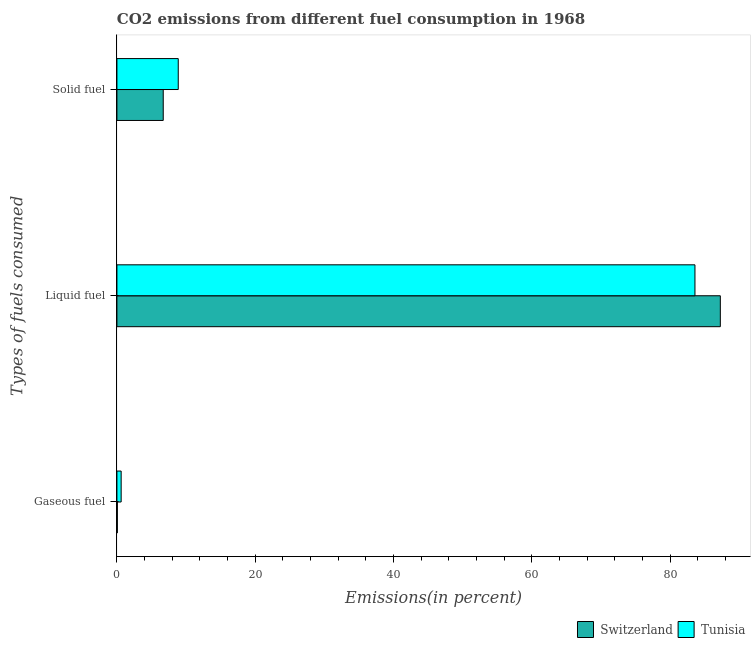How many groups of bars are there?
Your answer should be compact. 3. Are the number of bars per tick equal to the number of legend labels?
Make the answer very short. Yes. How many bars are there on the 2nd tick from the top?
Your answer should be compact. 2. How many bars are there on the 2nd tick from the bottom?
Give a very brief answer. 2. What is the label of the 3rd group of bars from the top?
Offer a very short reply. Gaseous fuel. What is the percentage of liquid fuel emission in Switzerland?
Give a very brief answer. 87.26. Across all countries, what is the maximum percentage of gaseous fuel emission?
Offer a very short reply. 0.61. Across all countries, what is the minimum percentage of liquid fuel emission?
Your answer should be very brief. 83.59. In which country was the percentage of solid fuel emission maximum?
Your answer should be compact. Tunisia. In which country was the percentage of liquid fuel emission minimum?
Your answer should be very brief. Tunisia. What is the total percentage of liquid fuel emission in the graph?
Your answer should be compact. 170.85. What is the difference between the percentage of liquid fuel emission in Tunisia and that in Switzerland?
Your answer should be very brief. -3.67. What is the difference between the percentage of liquid fuel emission in Tunisia and the percentage of gaseous fuel emission in Switzerland?
Give a very brief answer. 83.53. What is the average percentage of solid fuel emission per country?
Your answer should be very brief. 7.78. What is the difference between the percentage of liquid fuel emission and percentage of solid fuel emission in Switzerland?
Offer a terse response. 80.56. What is the ratio of the percentage of solid fuel emission in Switzerland to that in Tunisia?
Give a very brief answer. 0.76. Is the percentage of liquid fuel emission in Switzerland less than that in Tunisia?
Offer a terse response. No. What is the difference between the highest and the second highest percentage of gaseous fuel emission?
Offer a very short reply. 0.55. What is the difference between the highest and the lowest percentage of gaseous fuel emission?
Give a very brief answer. 0.55. What does the 2nd bar from the top in Liquid fuel represents?
Keep it short and to the point. Switzerland. What does the 1st bar from the bottom in Solid fuel represents?
Provide a succinct answer. Switzerland. How many bars are there?
Give a very brief answer. 6. Are all the bars in the graph horizontal?
Your answer should be very brief. Yes. Are the values on the major ticks of X-axis written in scientific E-notation?
Offer a terse response. No. Does the graph contain any zero values?
Ensure brevity in your answer.  No. Where does the legend appear in the graph?
Give a very brief answer. Bottom right. How are the legend labels stacked?
Your response must be concise. Horizontal. What is the title of the graph?
Your answer should be very brief. CO2 emissions from different fuel consumption in 1968. Does "Turkey" appear as one of the legend labels in the graph?
Provide a succinct answer. No. What is the label or title of the X-axis?
Keep it short and to the point. Emissions(in percent). What is the label or title of the Y-axis?
Offer a terse response. Types of fuels consumed. What is the Emissions(in percent) of Switzerland in Gaseous fuel?
Offer a very short reply. 0.06. What is the Emissions(in percent) in Tunisia in Gaseous fuel?
Give a very brief answer. 0.61. What is the Emissions(in percent) of Switzerland in Liquid fuel?
Your answer should be very brief. 87.26. What is the Emissions(in percent) of Tunisia in Liquid fuel?
Your answer should be very brief. 83.59. What is the Emissions(in percent) in Switzerland in Solid fuel?
Offer a terse response. 6.7. What is the Emissions(in percent) of Tunisia in Solid fuel?
Your answer should be compact. 8.87. Across all Types of fuels consumed, what is the maximum Emissions(in percent) in Switzerland?
Your answer should be compact. 87.26. Across all Types of fuels consumed, what is the maximum Emissions(in percent) of Tunisia?
Provide a succinct answer. 83.59. Across all Types of fuels consumed, what is the minimum Emissions(in percent) in Switzerland?
Make the answer very short. 0.06. Across all Types of fuels consumed, what is the minimum Emissions(in percent) of Tunisia?
Ensure brevity in your answer.  0.61. What is the total Emissions(in percent) of Switzerland in the graph?
Your answer should be compact. 94.02. What is the total Emissions(in percent) in Tunisia in the graph?
Provide a short and direct response. 93.07. What is the difference between the Emissions(in percent) of Switzerland in Gaseous fuel and that in Liquid fuel?
Provide a short and direct response. -87.2. What is the difference between the Emissions(in percent) in Tunisia in Gaseous fuel and that in Liquid fuel?
Provide a short and direct response. -82.98. What is the difference between the Emissions(in percent) in Switzerland in Gaseous fuel and that in Solid fuel?
Offer a terse response. -6.64. What is the difference between the Emissions(in percent) in Tunisia in Gaseous fuel and that in Solid fuel?
Offer a terse response. -8.26. What is the difference between the Emissions(in percent) of Switzerland in Liquid fuel and that in Solid fuel?
Offer a terse response. 80.56. What is the difference between the Emissions(in percent) of Tunisia in Liquid fuel and that in Solid fuel?
Make the answer very short. 74.72. What is the difference between the Emissions(in percent) in Switzerland in Gaseous fuel and the Emissions(in percent) in Tunisia in Liquid fuel?
Provide a succinct answer. -83.53. What is the difference between the Emissions(in percent) of Switzerland in Gaseous fuel and the Emissions(in percent) of Tunisia in Solid fuel?
Your response must be concise. -8.81. What is the difference between the Emissions(in percent) of Switzerland in Liquid fuel and the Emissions(in percent) of Tunisia in Solid fuel?
Offer a very short reply. 78.39. What is the average Emissions(in percent) of Switzerland per Types of fuels consumed?
Provide a short and direct response. 31.34. What is the average Emissions(in percent) of Tunisia per Types of fuels consumed?
Ensure brevity in your answer.  31.02. What is the difference between the Emissions(in percent) in Switzerland and Emissions(in percent) in Tunisia in Gaseous fuel?
Provide a short and direct response. -0.55. What is the difference between the Emissions(in percent) of Switzerland and Emissions(in percent) of Tunisia in Liquid fuel?
Your response must be concise. 3.67. What is the difference between the Emissions(in percent) of Switzerland and Emissions(in percent) of Tunisia in Solid fuel?
Make the answer very short. -2.17. What is the ratio of the Emissions(in percent) in Switzerland in Gaseous fuel to that in Liquid fuel?
Make the answer very short. 0. What is the ratio of the Emissions(in percent) of Tunisia in Gaseous fuel to that in Liquid fuel?
Ensure brevity in your answer.  0.01. What is the ratio of the Emissions(in percent) of Switzerland in Gaseous fuel to that in Solid fuel?
Provide a succinct answer. 0.01. What is the ratio of the Emissions(in percent) in Tunisia in Gaseous fuel to that in Solid fuel?
Your answer should be very brief. 0.07. What is the ratio of the Emissions(in percent) in Switzerland in Liquid fuel to that in Solid fuel?
Give a very brief answer. 13.03. What is the ratio of the Emissions(in percent) of Tunisia in Liquid fuel to that in Solid fuel?
Your response must be concise. 9.43. What is the difference between the highest and the second highest Emissions(in percent) in Switzerland?
Offer a terse response. 80.56. What is the difference between the highest and the second highest Emissions(in percent) in Tunisia?
Give a very brief answer. 74.72. What is the difference between the highest and the lowest Emissions(in percent) of Switzerland?
Your response must be concise. 87.2. What is the difference between the highest and the lowest Emissions(in percent) of Tunisia?
Offer a terse response. 82.98. 